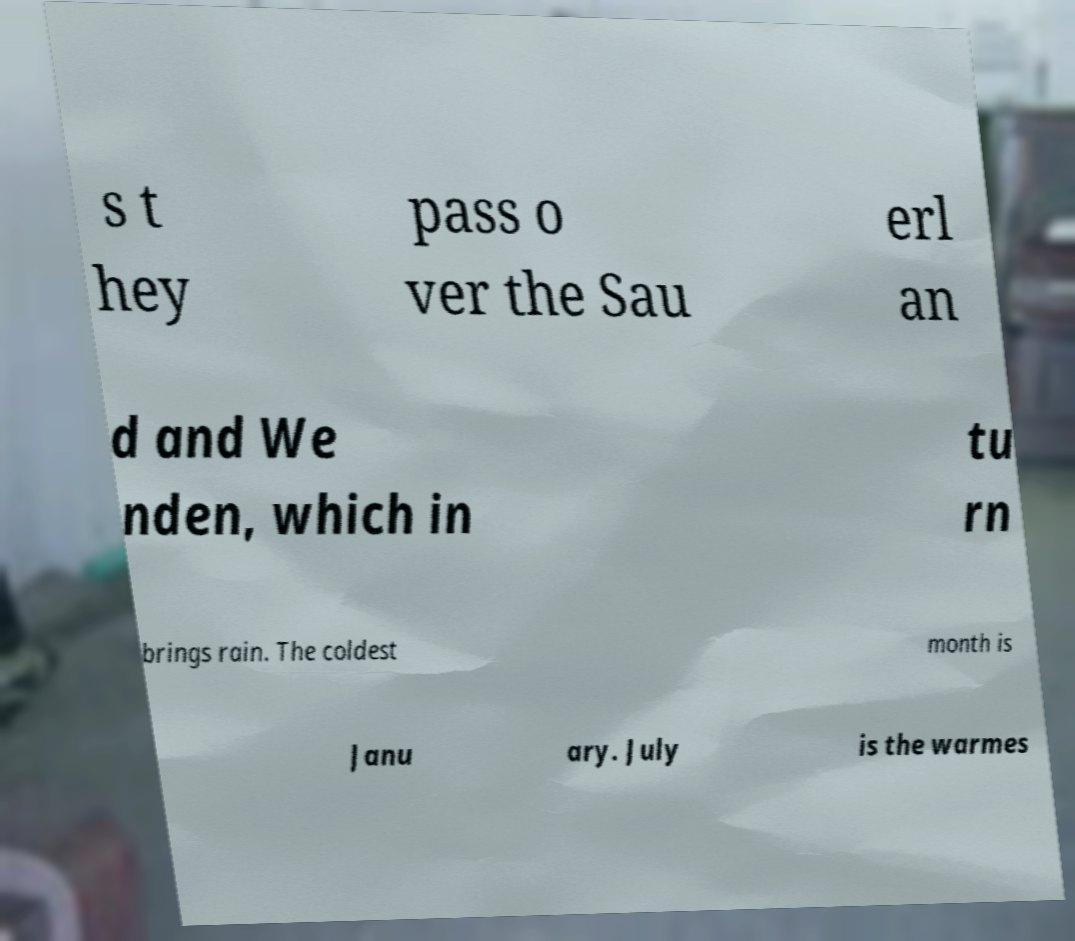For documentation purposes, I need the text within this image transcribed. Could you provide that? s t hey pass o ver the Sau erl an d and We nden, which in tu rn brings rain. The coldest month is Janu ary. July is the warmes 